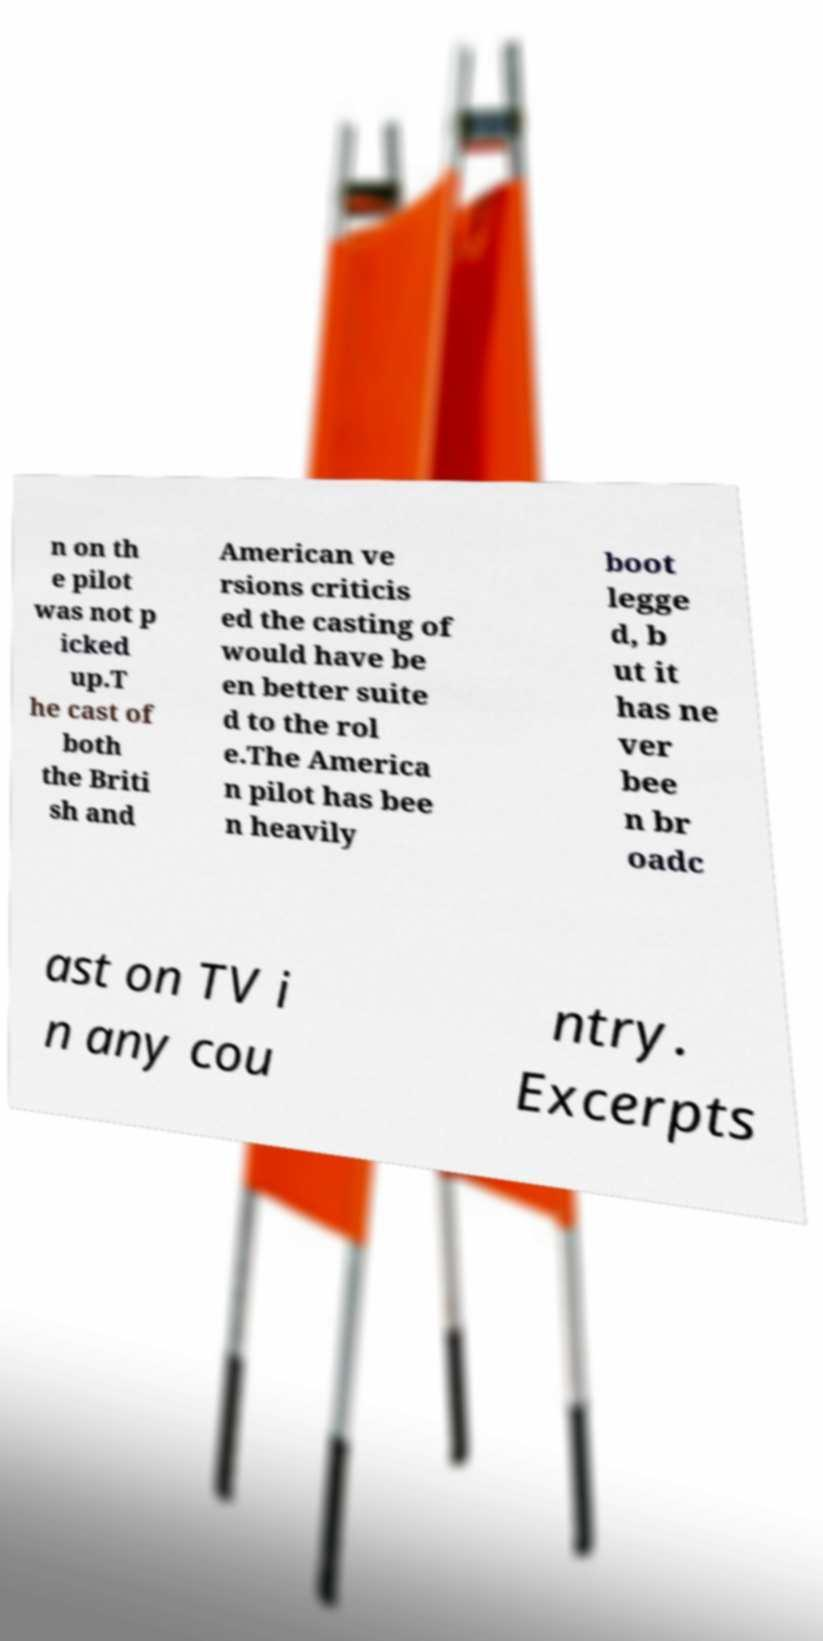Could you extract and type out the text from this image? n on th e pilot was not p icked up.T he cast of both the Briti sh and American ve rsions criticis ed the casting of would have be en better suite d to the rol e.The America n pilot has bee n heavily boot legge d, b ut it has ne ver bee n br oadc ast on TV i n any cou ntry. Excerpts 